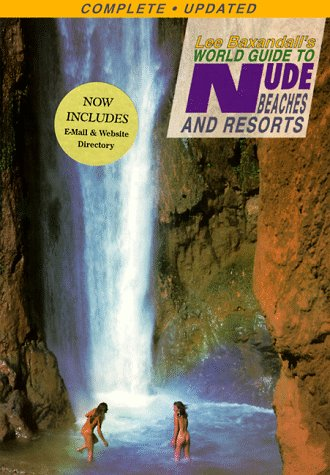Can you tell me something about the cover image of the book? The cover image features two individuals at a scenic waterfall, symbolizing the freedom and natural beauty associated with the book's destinations. 